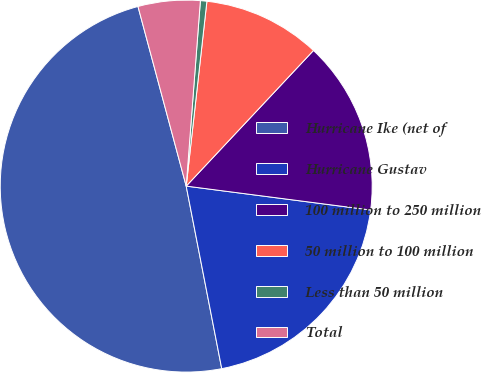Convert chart. <chart><loc_0><loc_0><loc_500><loc_500><pie_chart><fcel>Hurricane Ike (net of<fcel>Hurricane Gustav<fcel>100 million to 250 million<fcel>50 million to 100 million<fcel>Less than 50 million<fcel>Total<nl><fcel>48.89%<fcel>19.89%<fcel>15.06%<fcel>10.22%<fcel>0.56%<fcel>5.39%<nl></chart> 